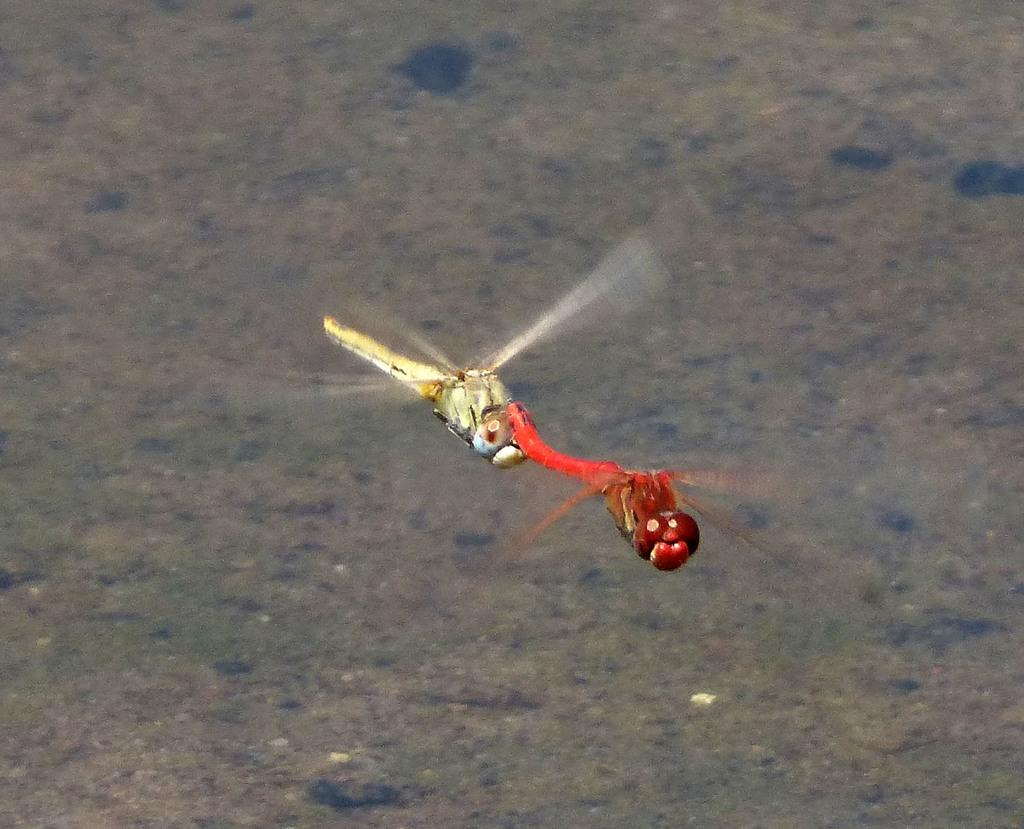What type of insects are present in the image? There are dragonflies in the image. Can you describe the background in the image? Unfortunately, the provided facts do not give any information about the background in the image. What type of whip is being used by the dragonflies in the image? There is no whip present in the image, as it features dragonflies and no such object is mentioned in the provided facts. 